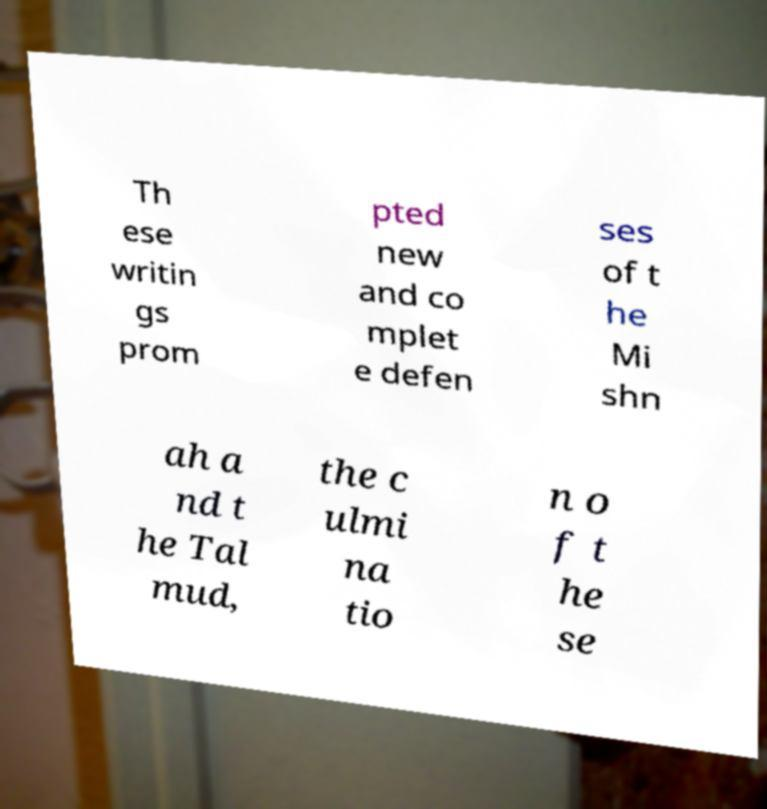Please read and relay the text visible in this image. What does it say? Th ese writin gs prom pted new and co mplet e defen ses of t he Mi shn ah a nd t he Tal mud, the c ulmi na tio n o f t he se 